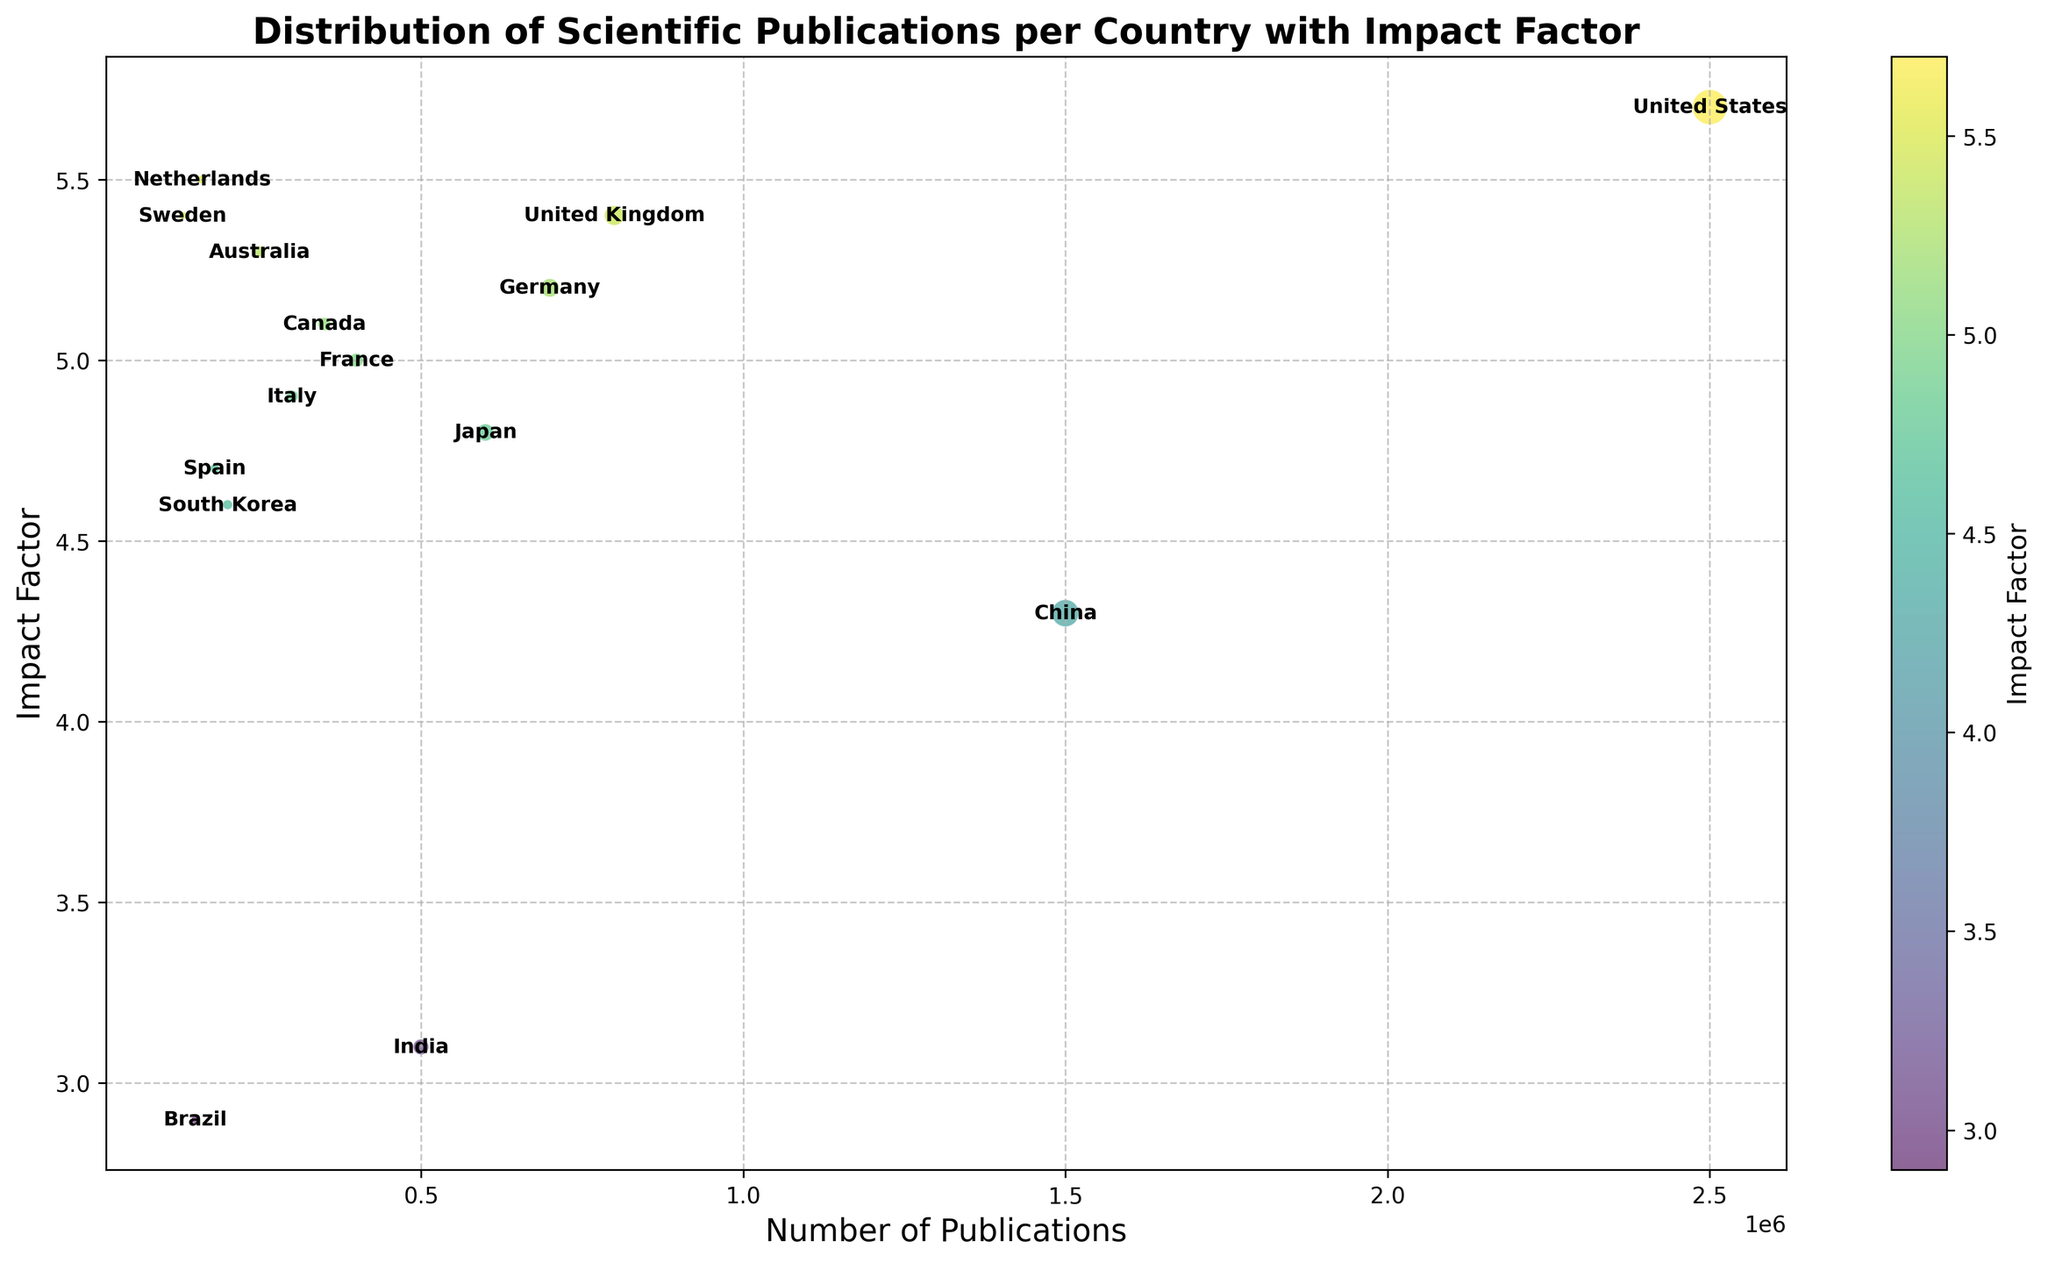What is the country with the highest number of publications? The country with the largest bubble represents the highest number of publications. According to the plot, the United States has the largest bubble.
Answer: United States How does the impact factor of the United Kingdom compare to that of Germany? Both countries' bubbles are colored according to their impact factors. The United Kingdom has an impact factor of 5.4, which is higher than Germany’s impact factor of 5.2.
Answer: The United Kingdom's impact factor is higher Which country has the highest impact factor color on the plot? The color bar on the right represents the impact factor. The Netherlands has the highest impact factor color, with a value of 5.5.
Answer: Netherlands What is the total number of publications for the top three countries? The top three countries by publication count are the United States (2,500,000), China (1,500,000), and the United Kingdom (800,000). The total is 2,500,000 + 1,500,000 + 800,000 = 4,800,000.
Answer: 4,800,000 Which country has a higher impact factor, Canada or Australia, and by how much? Both countries’ bubbles are checked by their position on the impact factor axis. Canada has an impact factor of 5.1, and Australia’s is 5.3. The difference is 5.3 - 5.1 = 0.2.
Answer: Australia by 0.2 What is the average impact factor of France and Italy? France has an impact factor of 5.0, and Italy’s is 4.9. The average impact factor is (5.0 + 4.9) / 2 = 4.95.
Answer: 4.95 Which country has a larger number of publications, Japan or India? By comparing the size of the bubbles, Japan has more publications (600,000) compared to India (500,000).
Answer: Japan Identify the country with the lowest impact factor among the ones presented? The color bar indicates that Brazil has the lowest impact factor of 2.9.
Answer: Brazil What is the combined impact factor of Sweden and the United Kingdom? The impact factor for Sweden is 5.4, and for the United Kingdom, it is also 5.4. Combined impact factor is 5.4 + 5.4 = 10.8.
Answer: 10.8 How does the publication count of India compare to Brazil? Both countries’ bubbles need to be compared. India has 500,000 publications, and Brazil has 150,000 publications. India has more publications.
Answer: India has more publications 